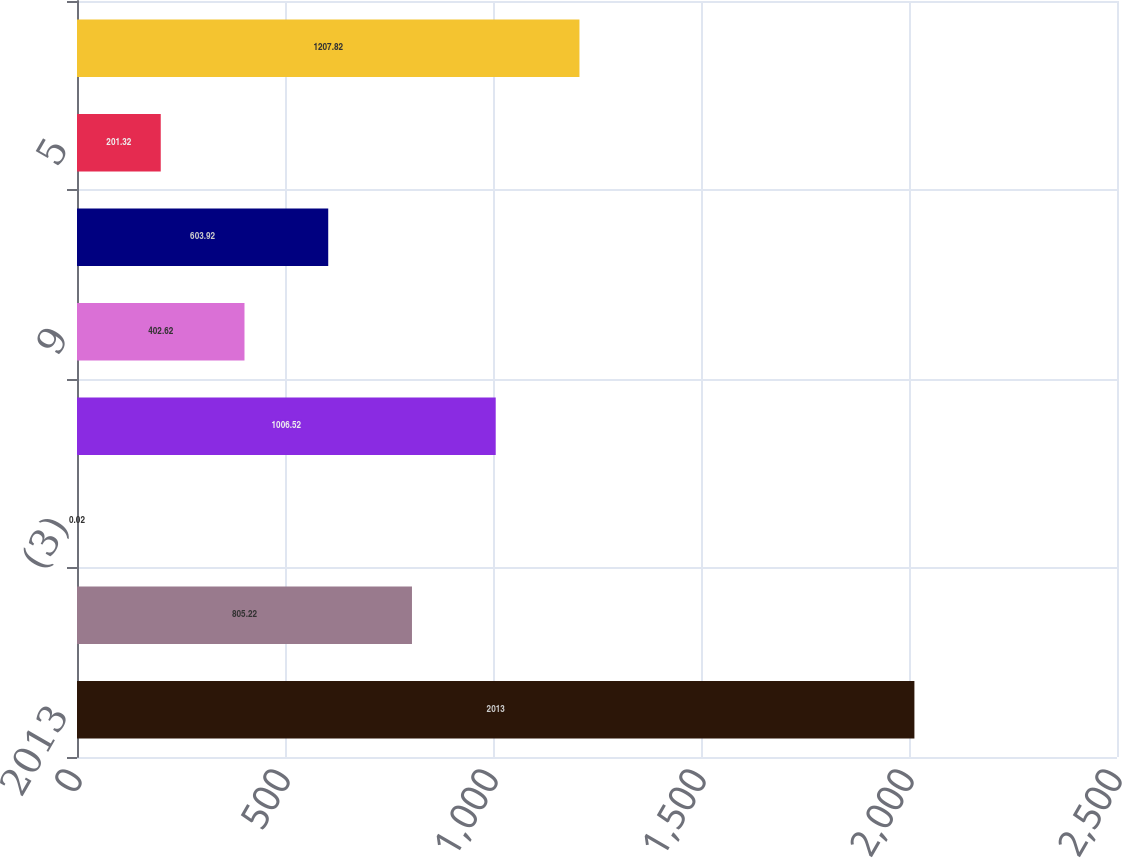Convert chart to OTSL. <chart><loc_0><loc_0><loc_500><loc_500><bar_chart><fcel>2013<fcel>1334<fcel>(3)<fcel>1337<fcel>9<fcel>111<fcel>5<fcel>1460<nl><fcel>2013<fcel>805.22<fcel>0.02<fcel>1006.52<fcel>402.62<fcel>603.92<fcel>201.32<fcel>1207.82<nl></chart> 